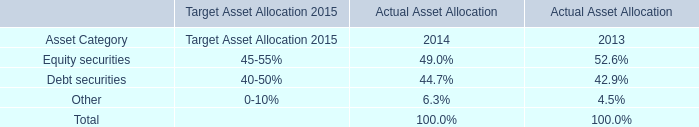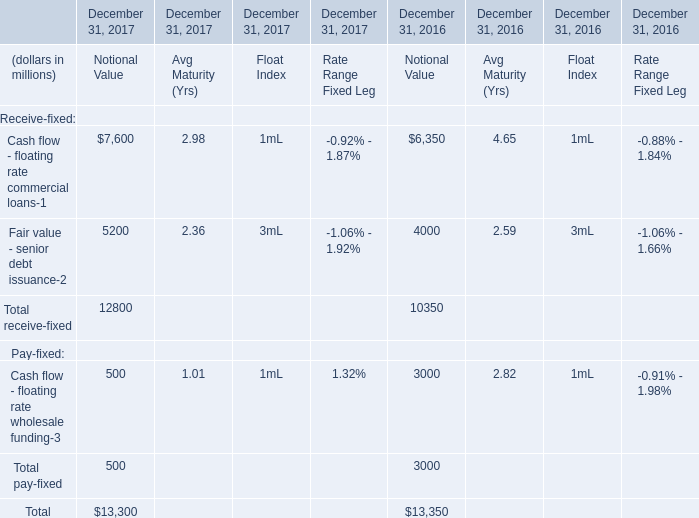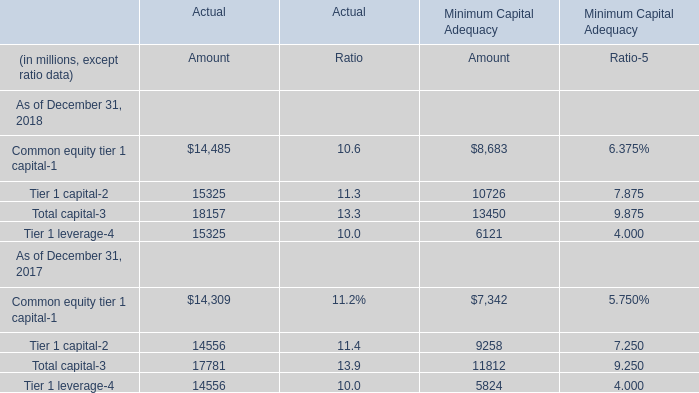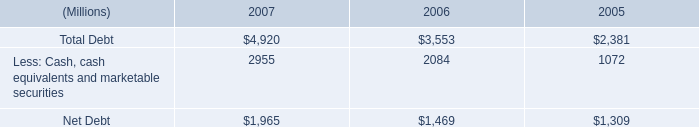What is the average amount of Net Debt of 2005, and Tier 1 leverage of Actual Amount ? 
Computations: ((1309.0 + 15325.0) / 2)
Answer: 8317.0. 